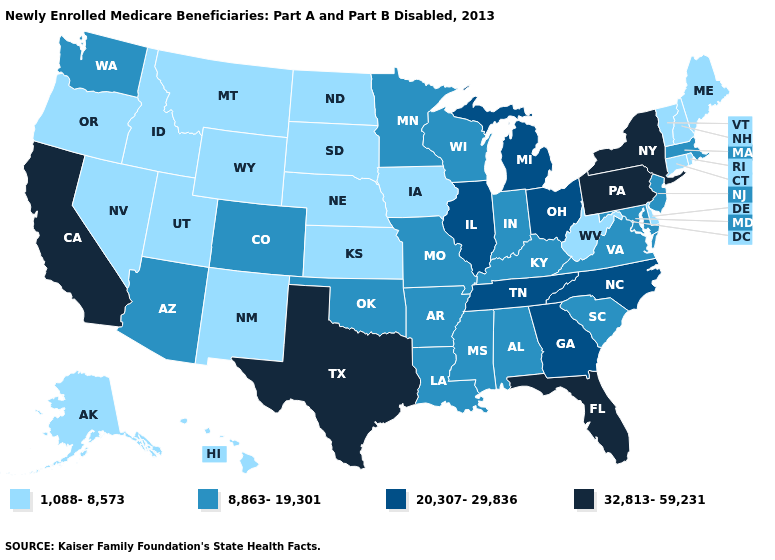Name the states that have a value in the range 1,088-8,573?
Be succinct. Alaska, Connecticut, Delaware, Hawaii, Idaho, Iowa, Kansas, Maine, Montana, Nebraska, Nevada, New Hampshire, New Mexico, North Dakota, Oregon, Rhode Island, South Dakota, Utah, Vermont, West Virginia, Wyoming. What is the value of Ohio?
Quick response, please. 20,307-29,836. Which states hav the highest value in the Northeast?
Short answer required. New York, Pennsylvania. Does California have the highest value in the West?
Keep it brief. Yes. What is the highest value in states that border South Dakota?
Answer briefly. 8,863-19,301. What is the lowest value in states that border South Dakota?
Write a very short answer. 1,088-8,573. Does Massachusetts have the lowest value in the Northeast?
Concise answer only. No. What is the lowest value in the USA?
Keep it brief. 1,088-8,573. How many symbols are there in the legend?
Short answer required. 4. Which states hav the highest value in the MidWest?
Write a very short answer. Illinois, Michigan, Ohio. Among the states that border Delaware , does Maryland have the lowest value?
Be succinct. Yes. Name the states that have a value in the range 20,307-29,836?
Write a very short answer. Georgia, Illinois, Michigan, North Carolina, Ohio, Tennessee. Does Florida have the highest value in the South?
Short answer required. Yes. Does Louisiana have the lowest value in the USA?
Concise answer only. No. What is the value of Ohio?
Be succinct. 20,307-29,836. 